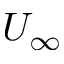Convert formula to latex. <formula><loc_0><loc_0><loc_500><loc_500>U _ { \infty }</formula> 